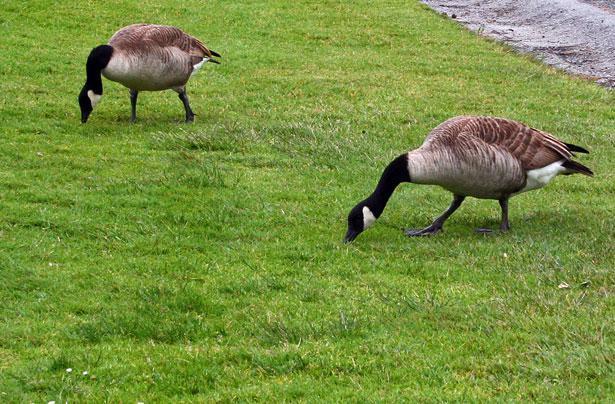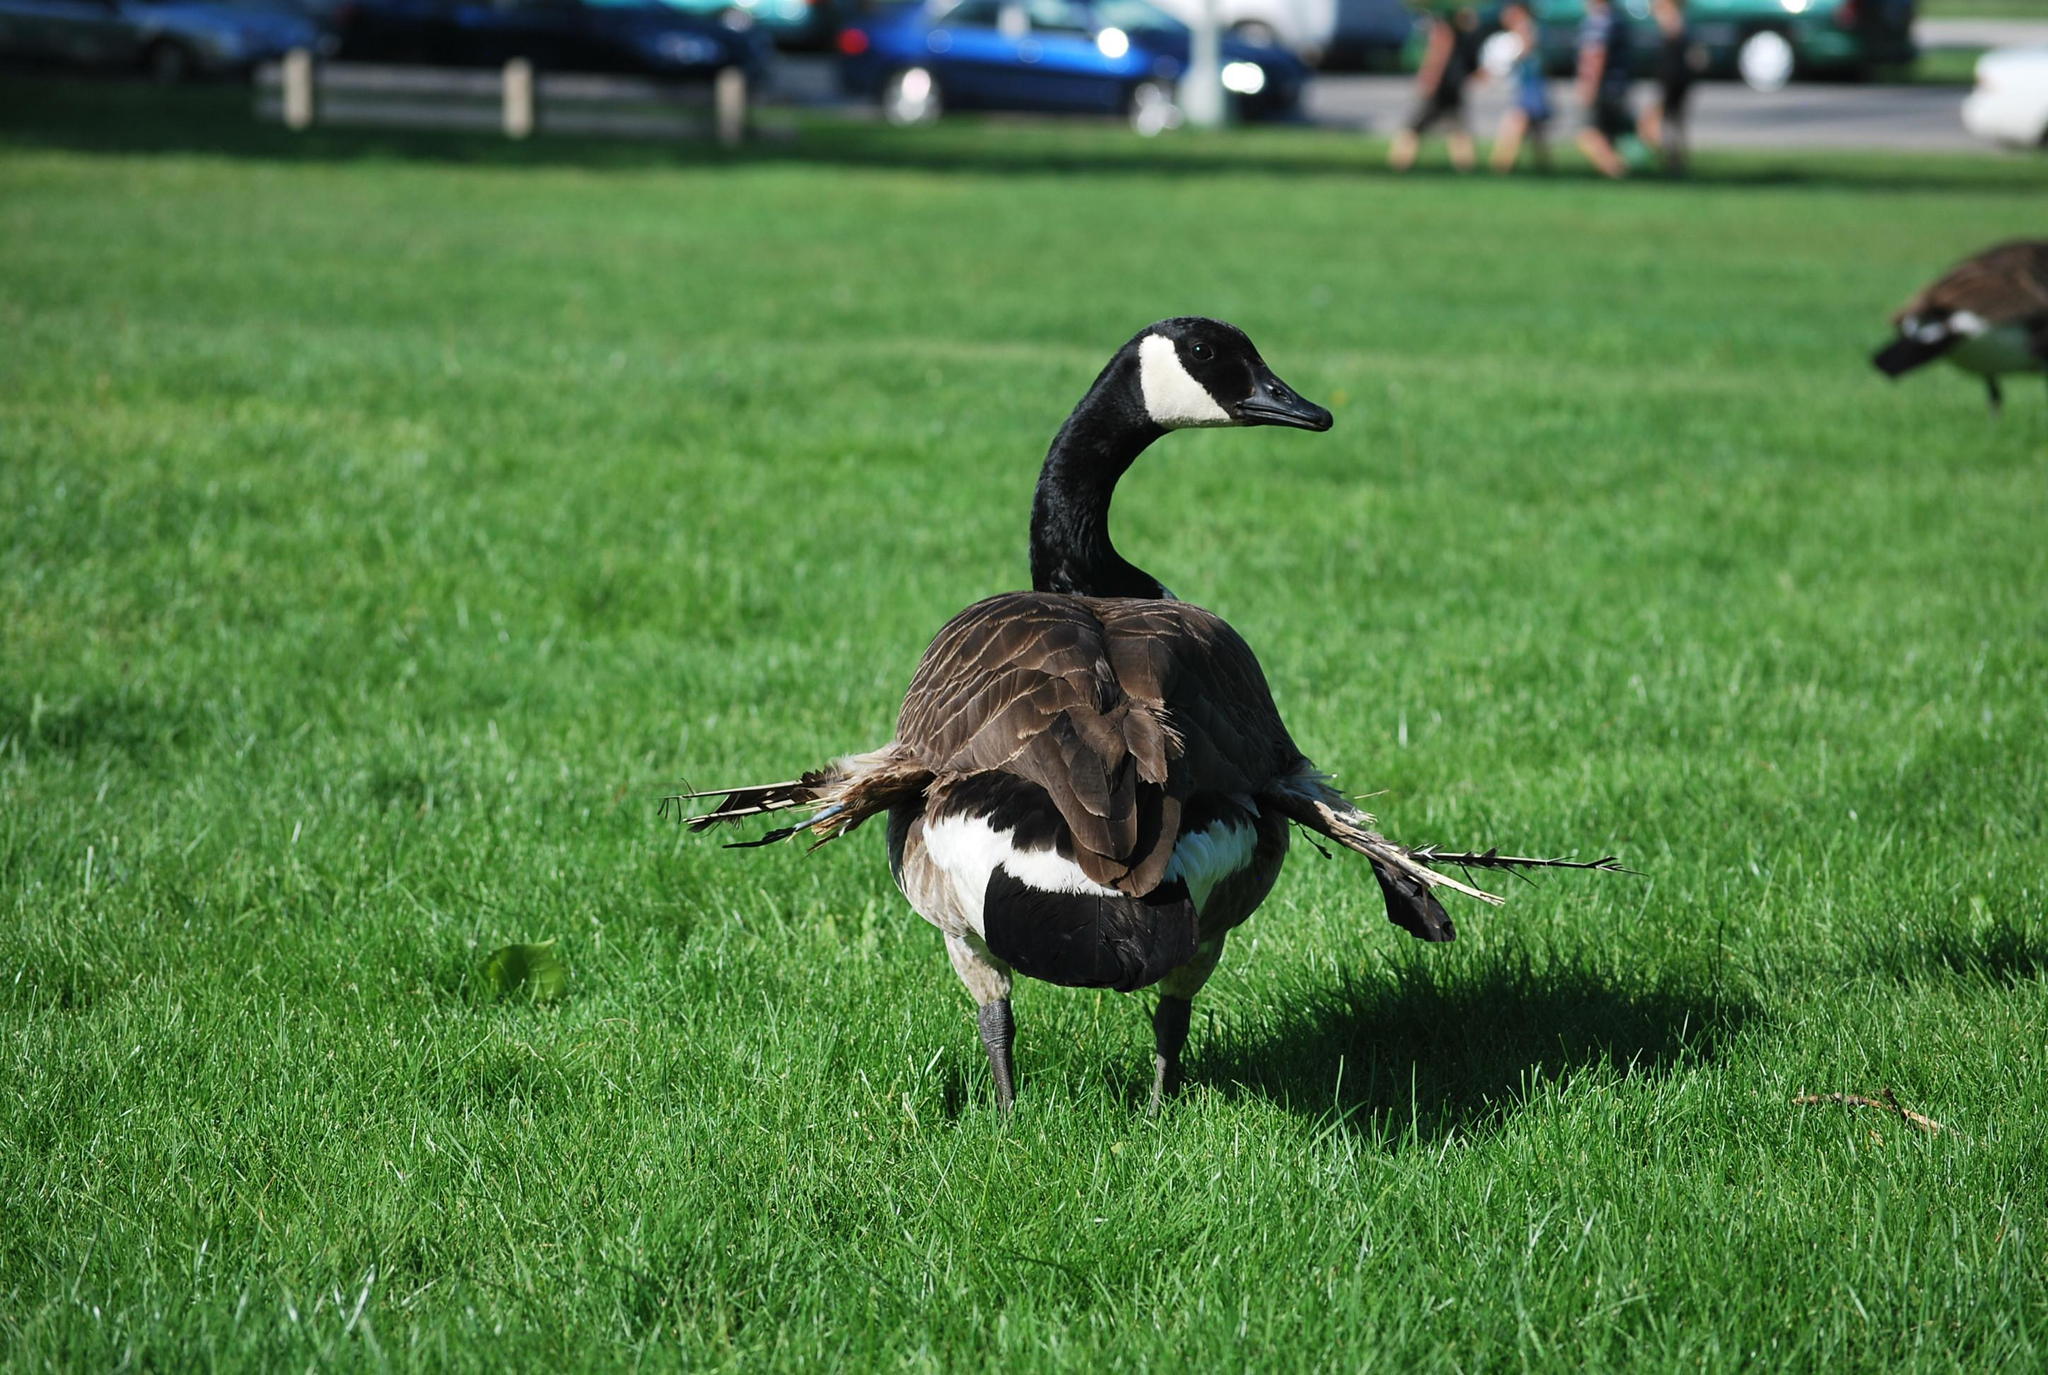The first image is the image on the left, the second image is the image on the right. Evaluate the accuracy of this statement regarding the images: "One image contains one grey goose with a grey neck who is standing upright with tucked wings, and the other image includes exactly two black necked geese with at least one bending its neck to the grass.". Is it true? Answer yes or no. No. The first image is the image on the left, the second image is the image on the right. Examine the images to the left and right. Is the description "One of the images features a single goose with an orange beak." accurate? Answer yes or no. No. 